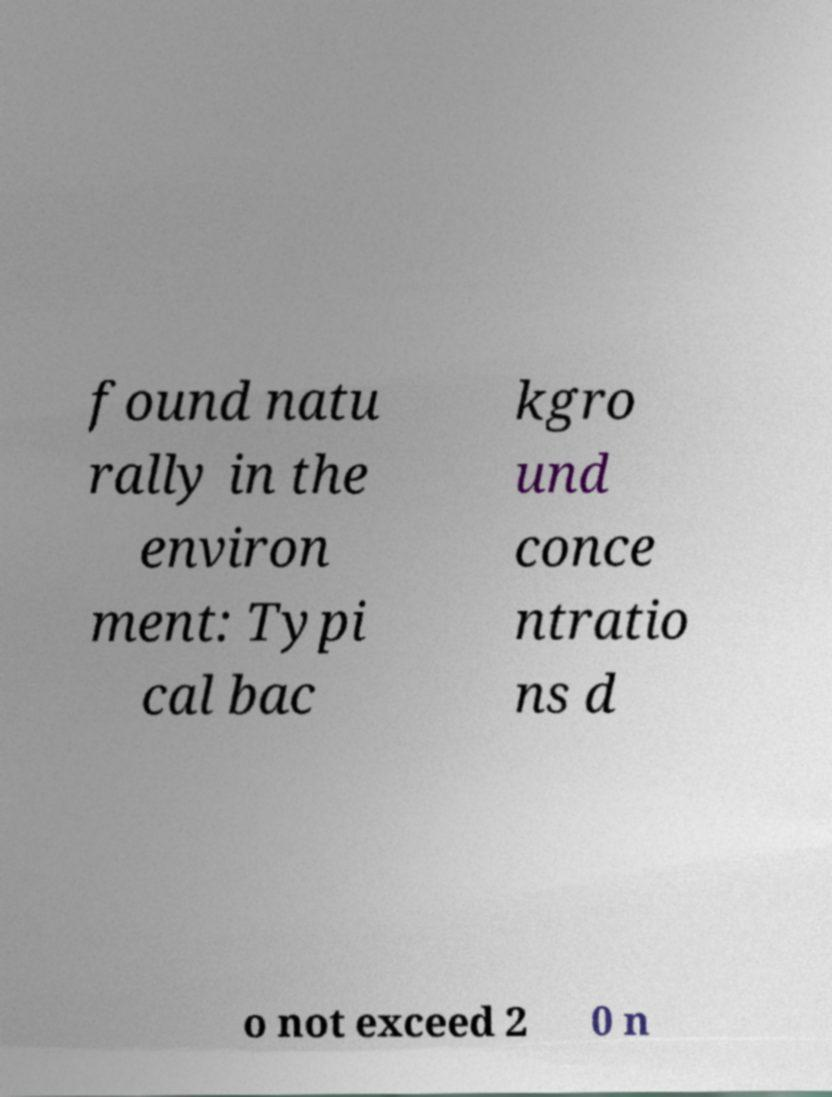There's text embedded in this image that I need extracted. Can you transcribe it verbatim? found natu rally in the environ ment: Typi cal bac kgro und conce ntratio ns d o not exceed 2 0 n 